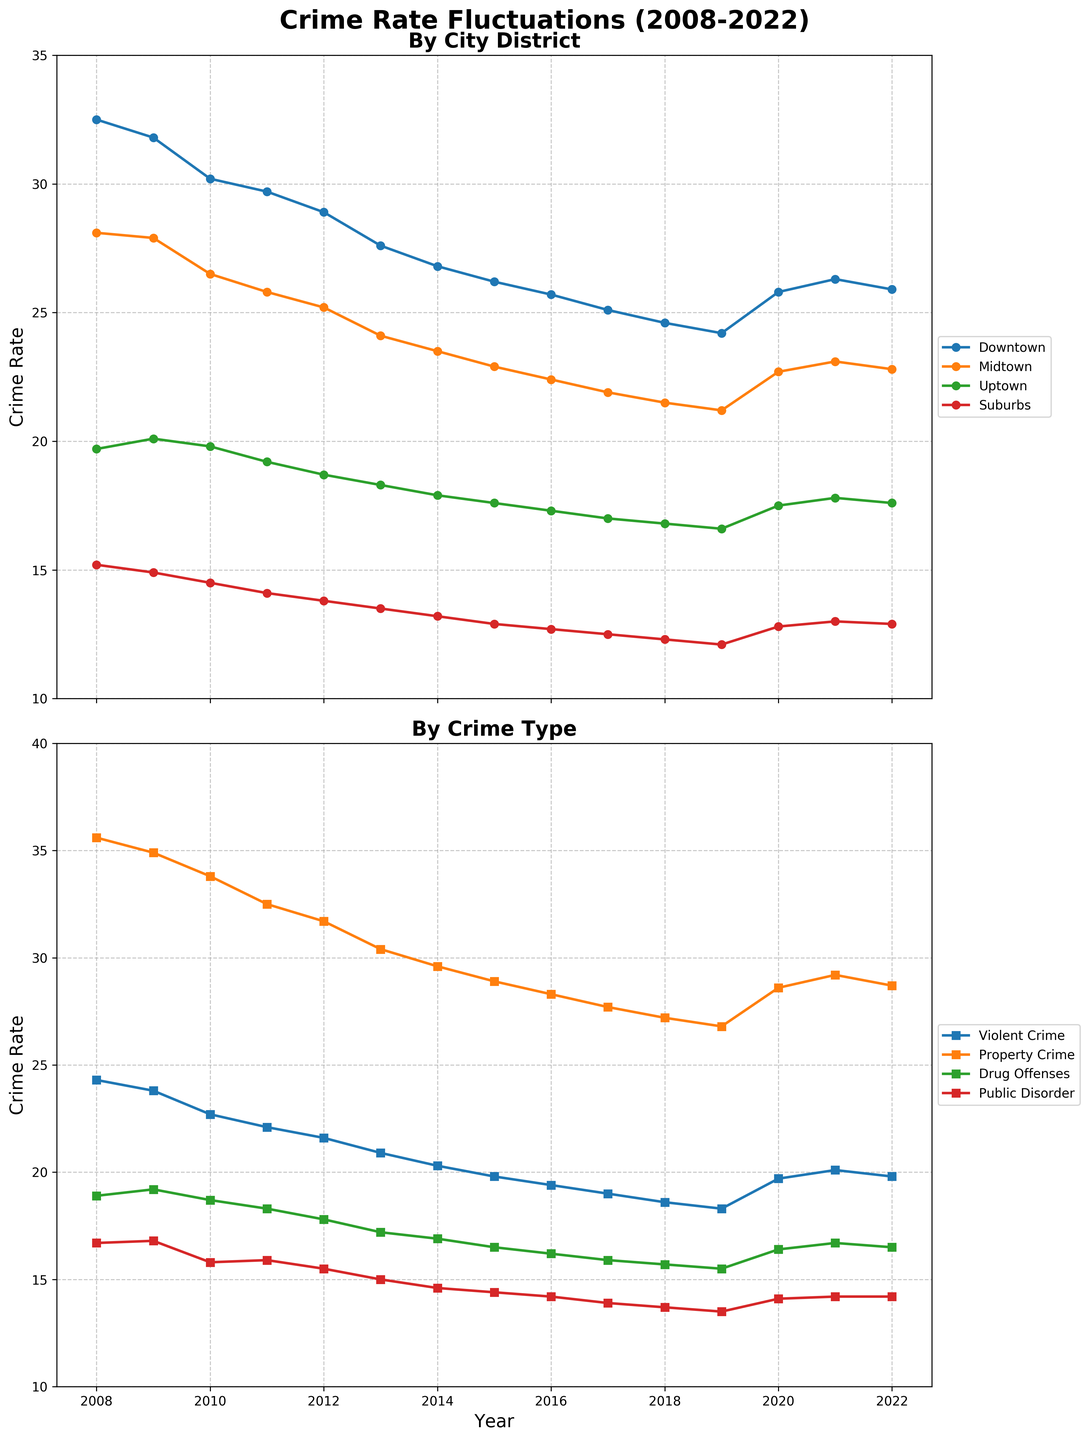Which district has the highest crime rate in 2022? In the top plot, the series for each district can be compared at the 2022 mark. Downtown has the highest point.
Answer: Downtown What is the overall trend for violent crimes from 2008 to 2022? In the bottom plot, observe the Violent Crime line from left (2008) to right (2022). It shows a declining trend from 2008 to 2019 and a slight increase after that.
Answer: Declining, with a slight increase after 2019 Compare the crime rate in Downtown and Suburbs in the year 2015. In the top plot, locate the points on the Downtown and Suburbs lines at the 2015 mark. Downtown's rate is about 26.2, and Suburbs' rate is about 12.9.
Answer: Downtown is higher than Suburbs What year did Midtown experience the lowest crime rate? Look for the lowest point in the Midtown series in the top plot. The lowest point is at 2019.
Answer: 2019 Calculate the average crime rate in Uptown from 2008 to 2022. Sum the Uptown values from the data (19.7+20.1+19.8+19.2+18.7+18.3+17.9+17.6+17.3+17.0+16.8+16.6+17.5+17.8+17.6) and divide by the number of years (15). (19.7+20.1+19.8+19.2+18.7+18.3+17.9+17.6+17.3+17.0+16.8+16.6+17.5+17.8+17.6)=271.9. Average = 271.9/15 = 18.13
Answer: 18.13 Which crime type had the largest decrease from 2008 to 2019? In the bottom plot, observe each crime type series from 2008 to 2019, and calculate the differences. Violent Crime: 24.3 - 18.3 = 6. Property Crime: 35.6 - 26.8 = 8.8. Drug Offenses: 18.9 - 15.5 = 3.4. Public Disorder: 16.7 - 13.5 = 3.2. Property Crime shows the largest decrease of 8.8.
Answer: Property Crime Which year saw a noticeable increase in Public Disorder offenses? Observe the Public Disorder series in the bottom plot for a noticeable upward movement. In the series, 2020 shows a noticeable increase from 13.5 to 14.1.
Answer: 2020 How does the change in violent crimes from 2019 to 2022 compare to the change in property crimes? Violent Crime went from 18.3 in 2019 to 19.8 in 2022, an increase of 1.5. Property Crime went from 26.8 in 2019 to 28.7 in 2022, an increase of 1.9.
Answer: Property Crime increase is larger What is the difference in crime rates between the highest rate district and lowest rate district in 2010? In the top plot for 2010, Downtown is the highest (30.2) and Suburbs is the lowest (14.5). Difference = 30.2 - 14.5 = 15.7
Answer: 15.7 Which district experienced the most consistent decline in crime rate over these years? Look for the most linear downward trend in the top plot. Midtown shows the most consistent decline from 28.1 in 2008 to 22.8 in 2022.
Answer: Midtown 